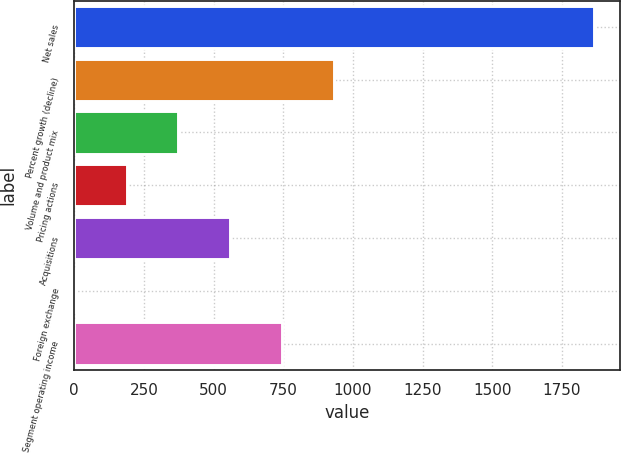Convert chart. <chart><loc_0><loc_0><loc_500><loc_500><bar_chart><fcel>Net sales<fcel>Percent growth (decline)<fcel>Volume and product mix<fcel>Pricing actions<fcel>Acquisitions<fcel>Foreign exchange<fcel>Segment operating income<nl><fcel>1864<fcel>932.8<fcel>374.08<fcel>187.84<fcel>560.32<fcel>1.6<fcel>746.56<nl></chart> 